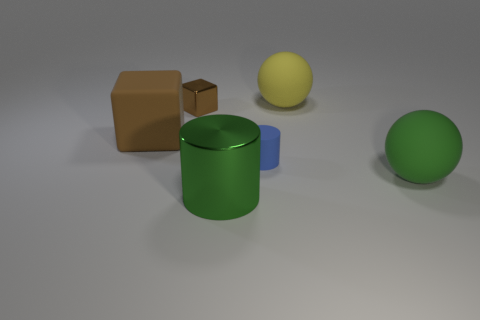Add 2 small metal cubes. How many objects exist? 8 Subtract all blocks. How many objects are left? 4 Add 4 green matte objects. How many green matte objects exist? 5 Subtract 1 blue cylinders. How many objects are left? 5 Subtract all metallic cylinders. Subtract all big green matte spheres. How many objects are left? 4 Add 2 tiny metal things. How many tiny metal things are left? 3 